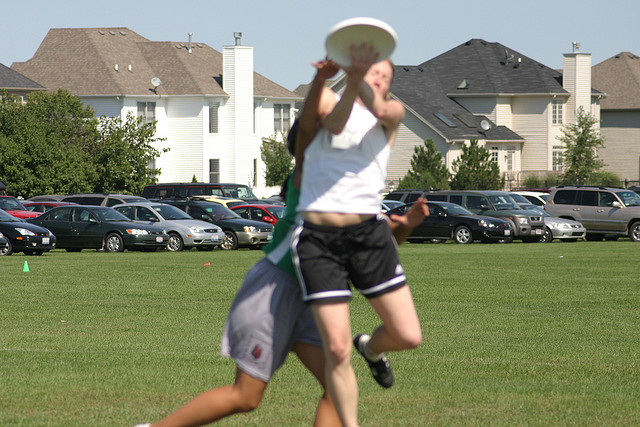<image>Are these women experienced in frisbee? I don't know if these women are experienced in frisbee. It's impossible to tell just by looking at them. Are these women experienced in frisbee? I am not sure if these women are experienced in frisbee. Some of them might be, but I cannot say for certain. 